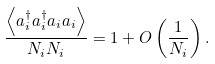<formula> <loc_0><loc_0><loc_500><loc_500>\frac { \left < a ^ { \dagger } _ { i } a ^ { \dagger } _ { i } a _ { i } a _ { i } \right > } { N _ { i } N _ { i } } = 1 + O \left ( \frac { 1 } { N _ { i } } \right ) .</formula> 